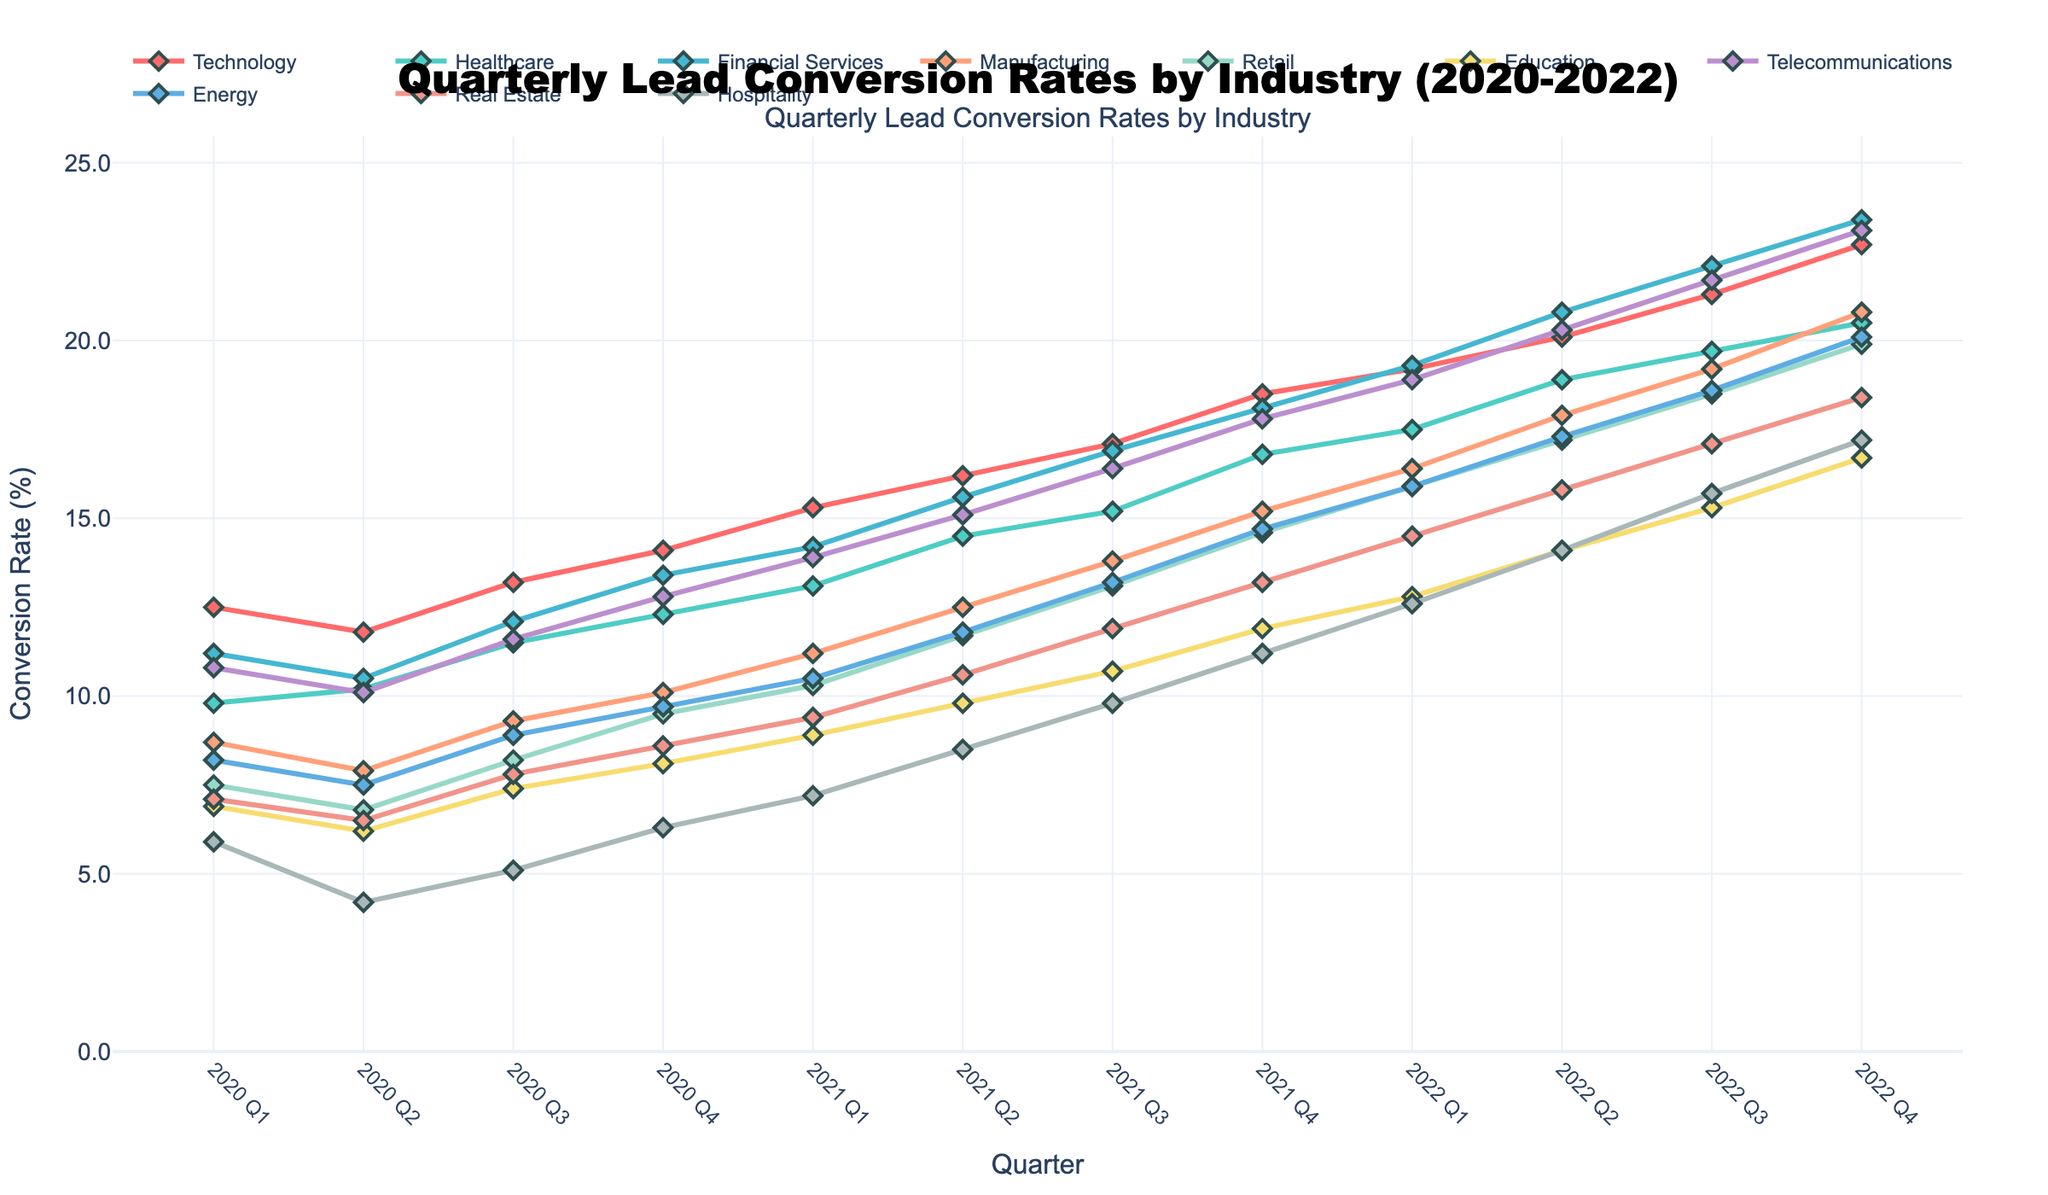What industry sector shows the highest lead conversion rate in 2022 Q4? By examining the data points at 2022 Q4 for each industry sector, Telecommunications sector has the highest conversion rate.
Answer: Telecommunications How does the conversion rate of Retail in 2022 Q4 compare to that in 2020 Q4? The conversion rate of Retail in 2022 Q4 is 19.9%, whereas in 2020 Q4, it was 9.5%. The difference is calculated as 19.9 - 9.5 = 10.4%.
Answer: 10.4% What is the average lead conversion rate for the Manufacturing sector across the four quarters of 2021? Summing up the conversion rates for Manufacturing in 2021 Q1 (11.2%), Q2 (12.5%), Q3 (13.8%), and Q4 (15.2%) and dividing by 4: (11.2 + 12.5 + 13.8 + 15.2) / 4 = 13.175%.
Answer: 13.2% Which industry sector had the lowest lead conversion rate in the third quarter of 2020? By checking the data for 2020 Q3, the industry with the lowest conversion rate is Hospitality, with 5.1%.
Answer: Hospitality How much did the Technology sector's conversion rate increase from 2021 Q2 to 2022 Q2? The Technology sector's conversion rate in 2021 Q2 was 16.2%, and in 2022 Q2, it was 20.1%. The increase is calculated as 20.1 - 16.2 = 3.9%.
Answer: 3.9% Which industry sector saw the biggest increase in lead conversion rate from 2020 Q1 to 2022 Q4? By calculating the difference between 2020 Q1 and 2022 Q4 for each industry, Telecommunications had the largest increase: 23.1% - 10.8% = 12.3%.
Answer: Telecommunications What is the median lead conversion rate for the Healthcare sector over the entire period? The conversion rates for Healthcare are: 9.8, 10.2, 11.5, 12.3, 13.1, 14.5, 15.2, 16.8, 17.5, 18.9, 19.7, 20.5. The median is the average of the 6th and 7th values: (14.5 + 15.2) / 2 = 14.85%.
Answer: 14.9% Between the Financial Services and Energy sectors, which had a higher conversion rate in 2021 Q4? The conversion rate for Financial Services in 2021 Q4 was 18.1%, while for Energy, it was 14.7%. Financial Services has the higher rate.
Answer: Financial Services What was the total increase in conversion rate for the Education sector from 2020 Q1 to 2022 Q4? The conversion rate for Education in 2020 Q1 was 6.9%, and in 2022 Q4, it was 16.7%. The total increase is 16.7 - 6.9 = 9.8%.
Answer: 9.8% Did any industry sector have a decrease in lead conversion rate from 2022 Q3 to 2022 Q4? Comparing the data points for 2022 Q3 and 2022 Q4 for all sectors, no industry showed a decrease; all showed an increase or remained the same.
Answer: No 